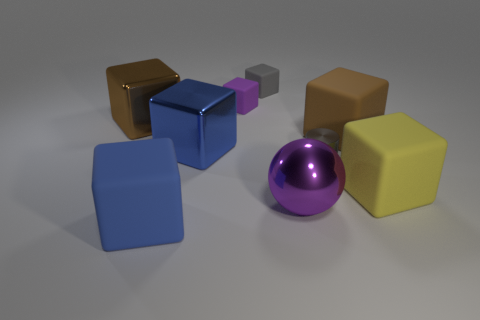Subtract all large blue metal blocks. How many blocks are left? 6 Subtract all brown cylinders. How many brown cubes are left? 2 Subtract all blue blocks. How many blocks are left? 5 Subtract 5 cubes. How many cubes are left? 2 Subtract 1 purple blocks. How many objects are left? 8 Subtract all cylinders. How many objects are left? 8 Subtract all gray blocks. Subtract all cyan cylinders. How many blocks are left? 6 Subtract all rubber objects. Subtract all yellow rubber objects. How many objects are left? 3 Add 4 big brown matte things. How many big brown matte things are left? 5 Add 7 gray rubber things. How many gray rubber things exist? 8 